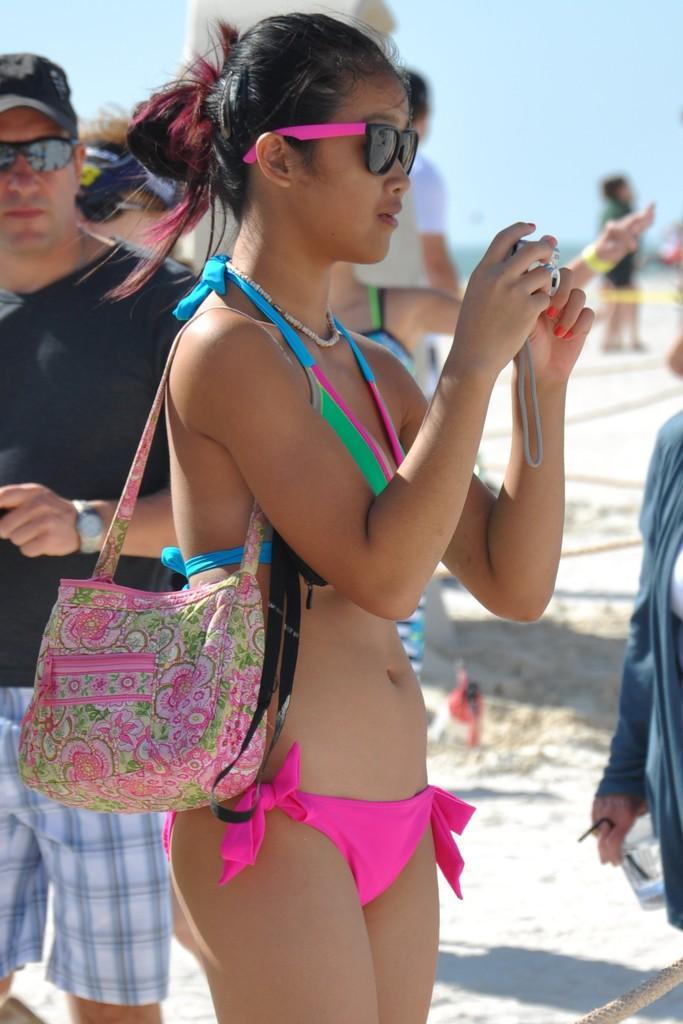Please provide a concise description of this image. The lady wearing bikini is carrying a pink handbag and holding a camera in her hand and there is a person wearing black shirt behind her. 